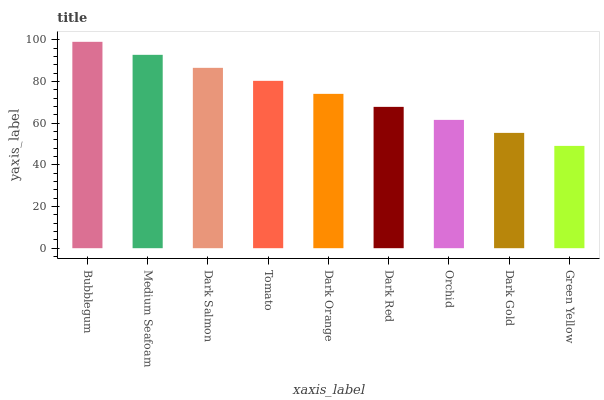Is Medium Seafoam the minimum?
Answer yes or no. No. Is Medium Seafoam the maximum?
Answer yes or no. No. Is Bubblegum greater than Medium Seafoam?
Answer yes or no. Yes. Is Medium Seafoam less than Bubblegum?
Answer yes or no. Yes. Is Medium Seafoam greater than Bubblegum?
Answer yes or no. No. Is Bubblegum less than Medium Seafoam?
Answer yes or no. No. Is Dark Orange the high median?
Answer yes or no. Yes. Is Dark Orange the low median?
Answer yes or no. Yes. Is Orchid the high median?
Answer yes or no. No. Is Green Yellow the low median?
Answer yes or no. No. 